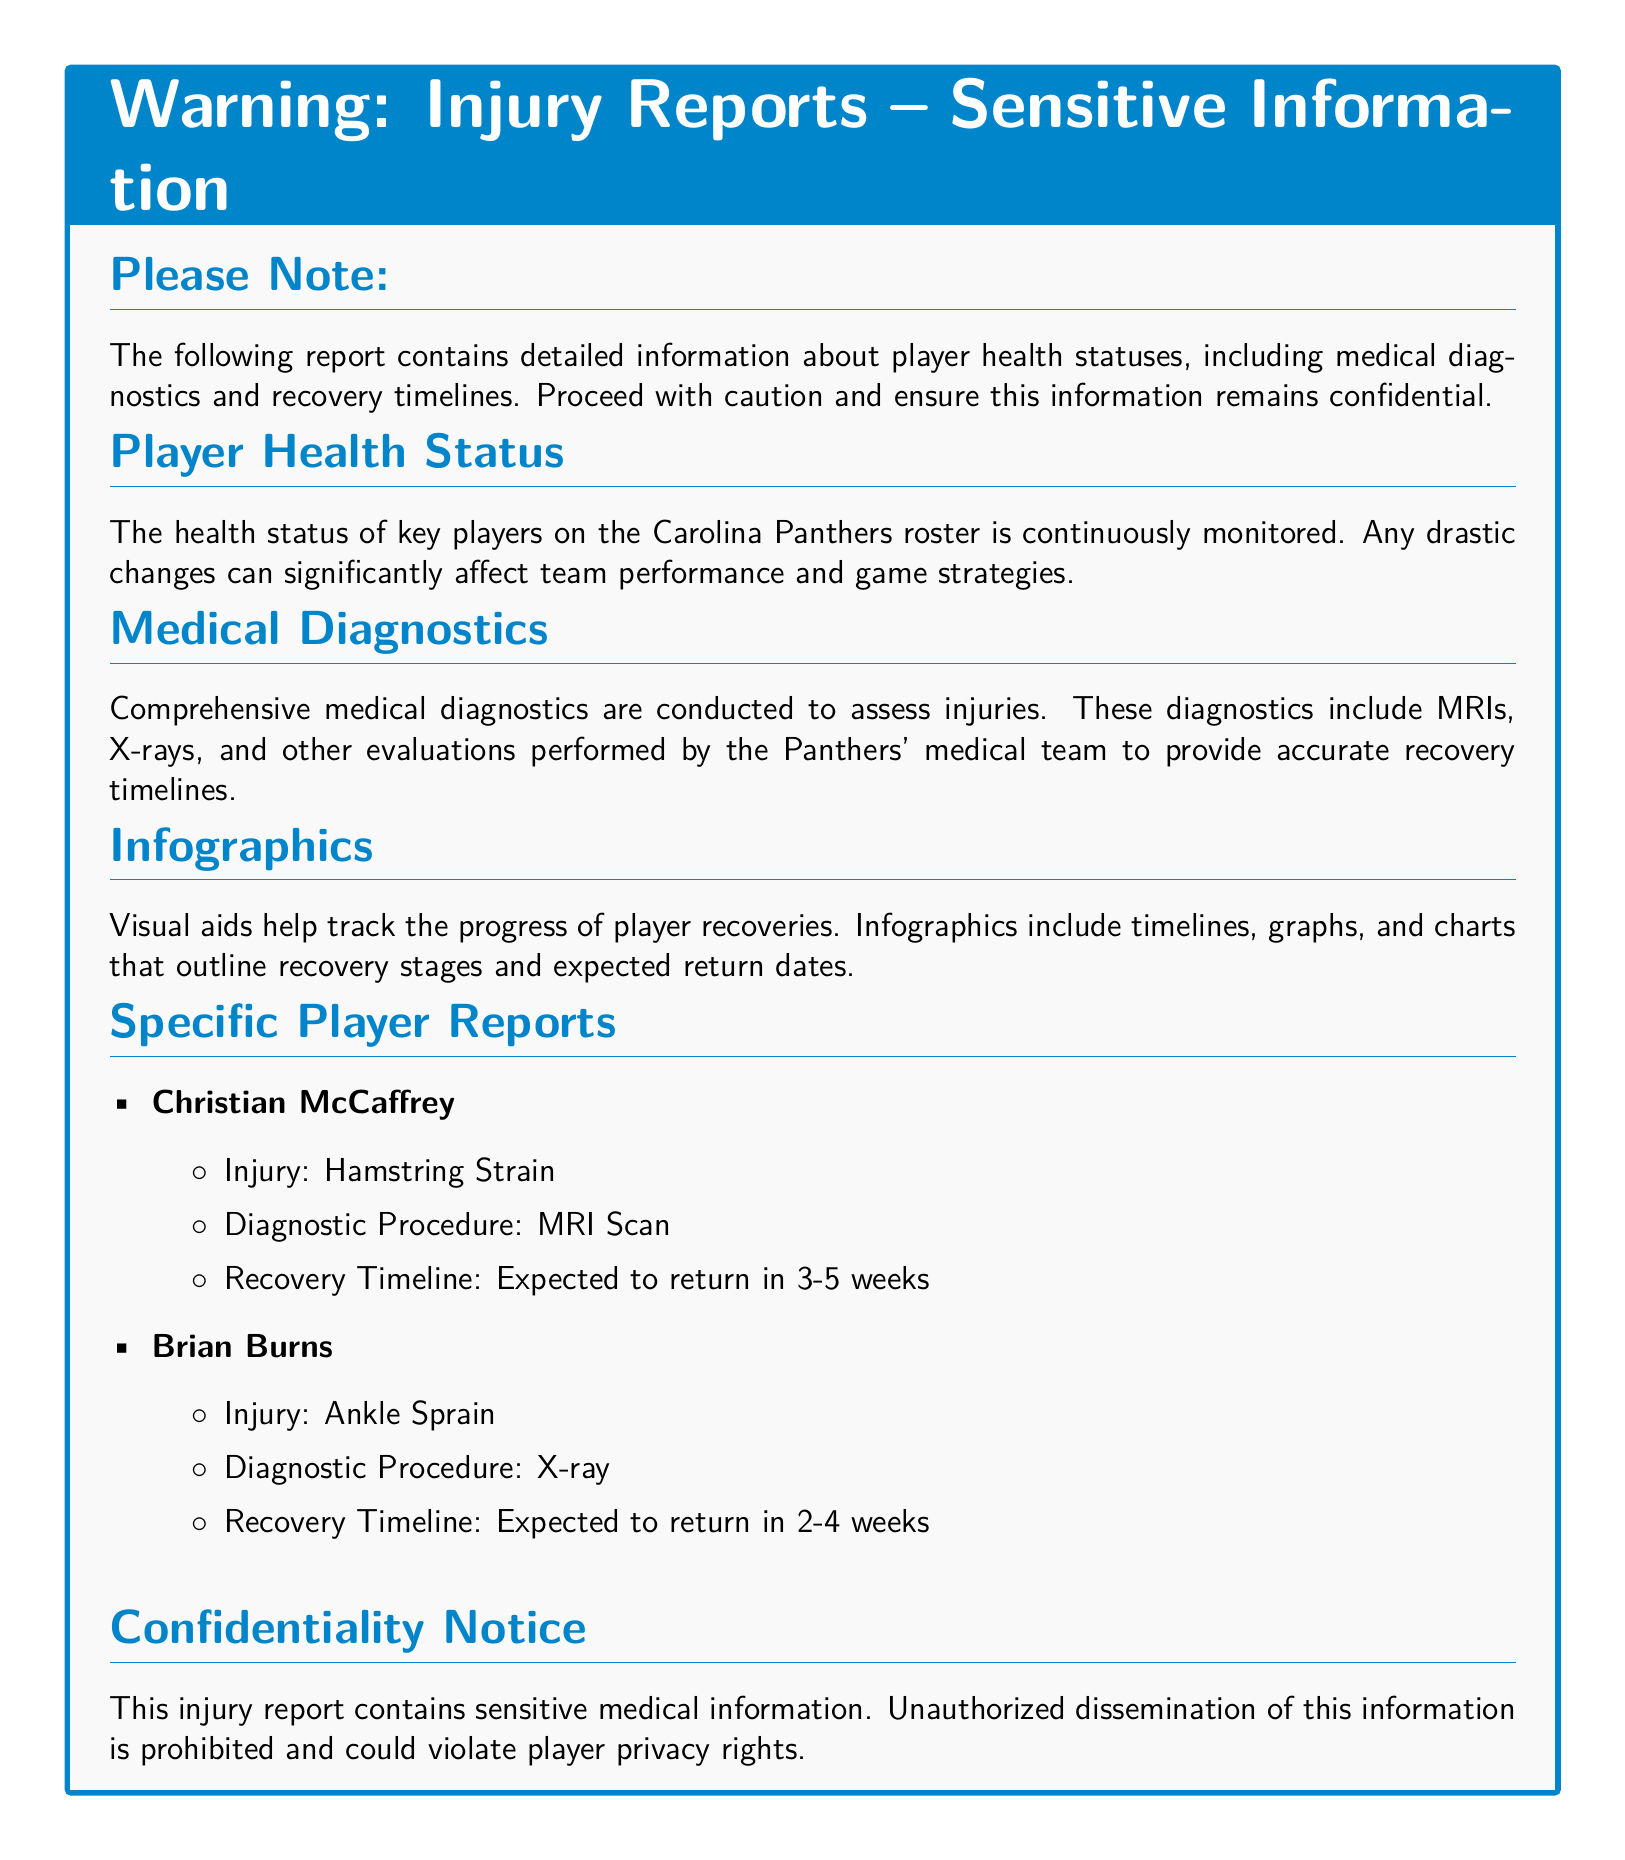What is the title of the document? The title is prominently displayed in the document and describes the sensitivity of the information contained within.
Answer: Warning: Injury Reports – Sensitive Information What is the recovery timeline for Christian McCaffrey? The document provides specific timelines for player recoveries, including that of Christian McCaffrey under 'Specific Player Reports'.
Answer: Expected to return in 3-5 weeks What type of injury does Brian Burns have? The document lists the injuries for key players, including Brian Burns, under 'Specific Player Reports'.
Answer: Ankle Sprain What diagnostic procedure was used for Christian McCaffrey? The document describes diagnostic procedures for injuries, specifically mentioning the assessment for Christian McCaffrey.
Answer: MRI Scan What type of visual aids are included in the report? The report mentions the use of visual aids specifically related to tracking recovery processes.
Answer: Infographics What is indicated about the confidentiality of the injury report? The document ensures readers understand the importance of protecting sensitive information mentioned in the confidentiality notice.
Answer: Unauthorized dissemination is prohibited How often is player health monitored? The document states that the health status of players is continuously monitored, indicating how frequently the assessment is done.
Answer: Continuously What is a consequence of unauthorized dissemination of the report? The document states specific consequences related to violating player privacy rights, emphasizing the importance of confidentiality.
Answer: Violate player privacy rights 